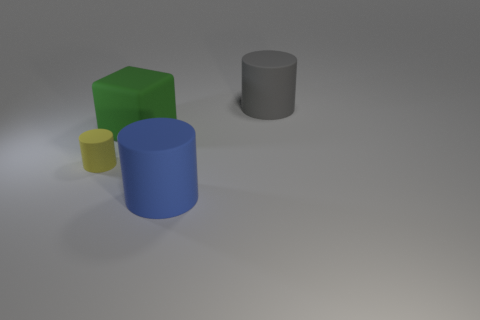Subtract all blue cylinders. How many cylinders are left? 2 Add 3 green rubber objects. How many objects exist? 7 Subtract all blue cylinders. How many cylinders are left? 2 Subtract all blocks. How many objects are left? 3 Subtract 1 cylinders. How many cylinders are left? 2 Subtract all brown cylinders. Subtract all yellow balls. How many cylinders are left? 3 Subtract all brown blocks. How many yellow cylinders are left? 1 Subtract all brown metal balls. Subtract all tiny things. How many objects are left? 3 Add 2 small yellow matte cylinders. How many small yellow matte cylinders are left? 3 Add 3 tiny blue things. How many tiny blue things exist? 3 